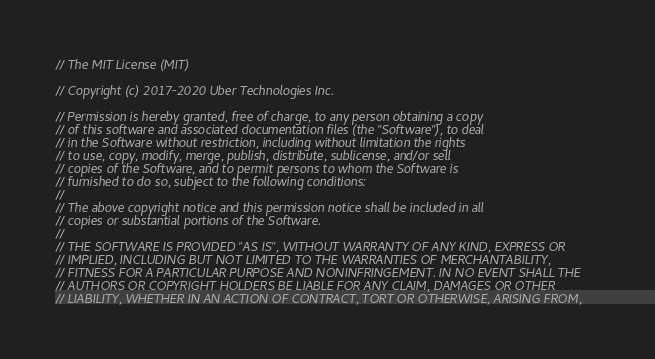<code> <loc_0><loc_0><loc_500><loc_500><_Go_>// The MIT License (MIT)

// Copyright (c) 2017-2020 Uber Technologies Inc.

// Permission is hereby granted, free of charge, to any person obtaining a copy
// of this software and associated documentation files (the "Software"), to deal
// in the Software without restriction, including without limitation the rights
// to use, copy, modify, merge, publish, distribute, sublicense, and/or sell
// copies of the Software, and to permit persons to whom the Software is
// furnished to do so, subject to the following conditions:
//
// The above copyright notice and this permission notice shall be included in all
// copies or substantial portions of the Software.
//
// THE SOFTWARE IS PROVIDED "AS IS", WITHOUT WARRANTY OF ANY KIND, EXPRESS OR
// IMPLIED, INCLUDING BUT NOT LIMITED TO THE WARRANTIES OF MERCHANTABILITY,
// FITNESS FOR A PARTICULAR PURPOSE AND NONINFRINGEMENT. IN NO EVENT SHALL THE
// AUTHORS OR COPYRIGHT HOLDERS BE LIABLE FOR ANY CLAIM, DAMAGES OR OTHER
// LIABILITY, WHETHER IN AN ACTION OF CONTRACT, TORT OR OTHERWISE, ARISING FROM,</code> 